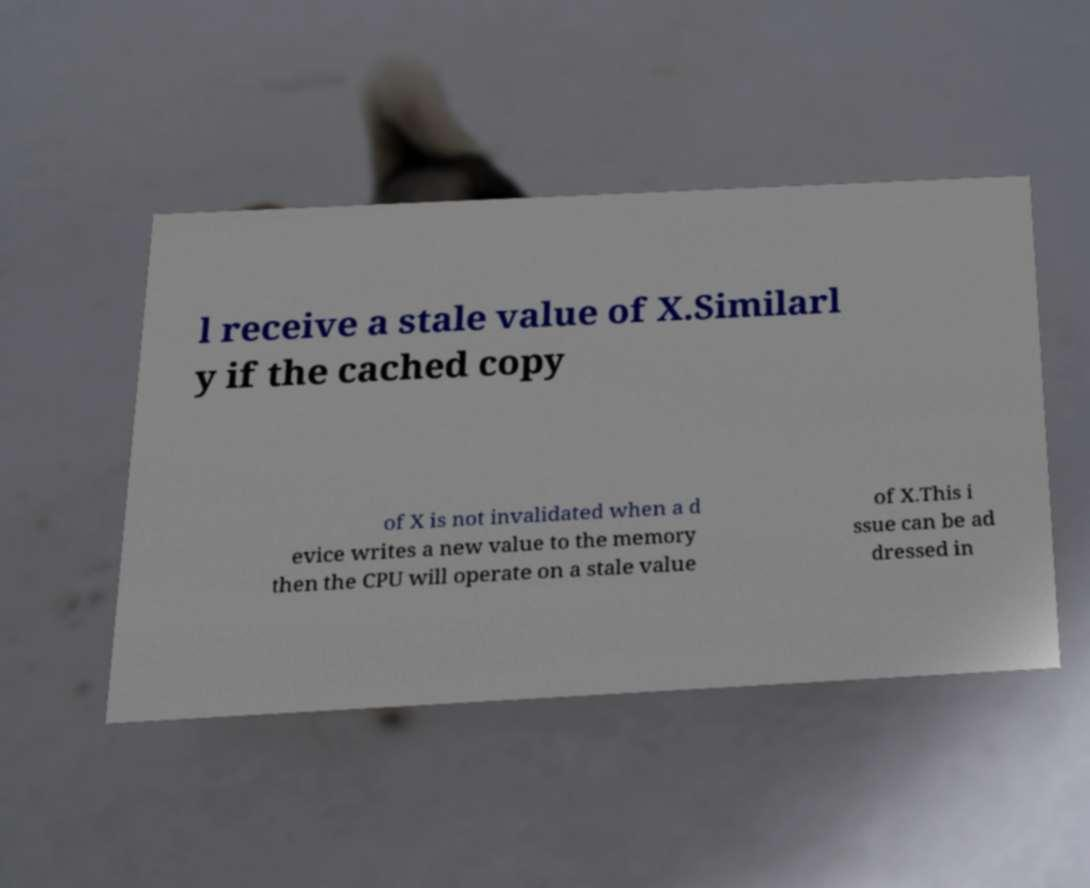Could you assist in decoding the text presented in this image and type it out clearly? l receive a stale value of X.Similarl y if the cached copy of X is not invalidated when a d evice writes a new value to the memory then the CPU will operate on a stale value of X.This i ssue can be ad dressed in 